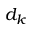Convert formula to latex. <formula><loc_0><loc_0><loc_500><loc_500>d _ { k }</formula> 